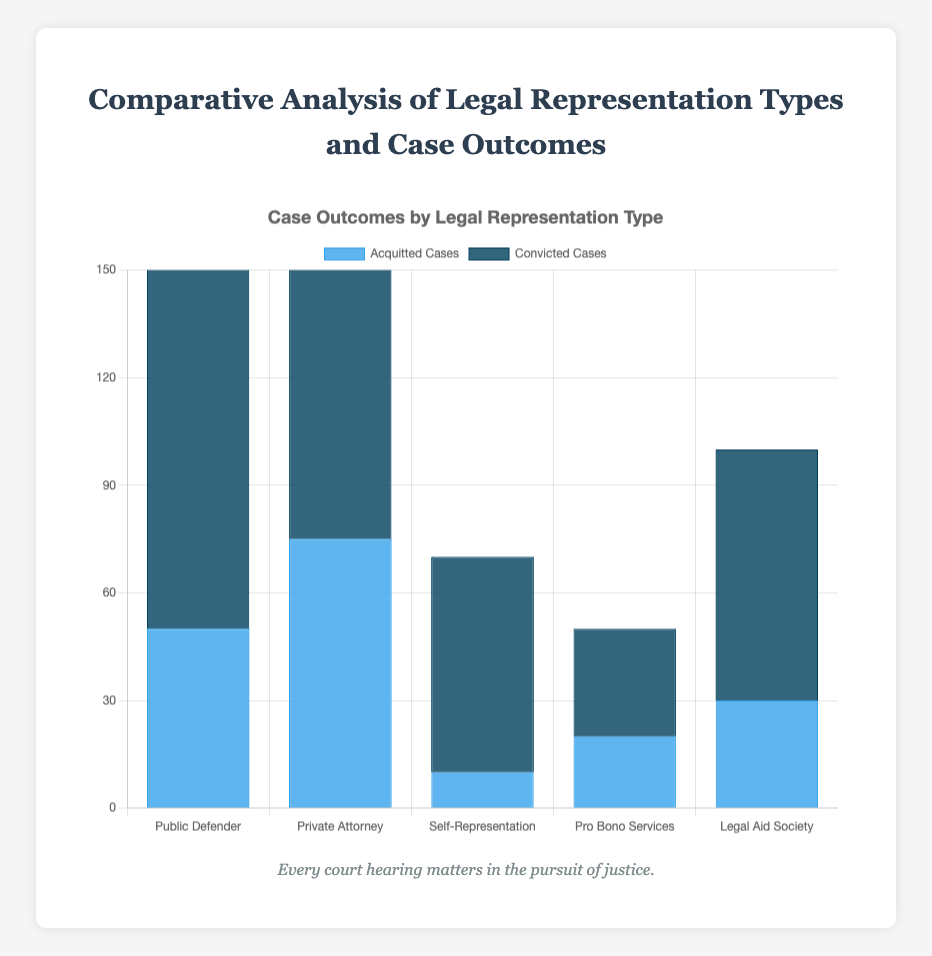What is the total number of acquitted cases for all legal representation types combined? Sum the individual acquitted cases: 50 (Public Defender) + 75 (Private Attorney) + 10 (Self-Representation) + 20 (Pro Bono Services) + 30 (Legal Aid Society) = 185
Answer: 185 Which legal representation type has the highest number of acquitted cases? Compare the acquitted cases across all types: 50 (Public Defender), 75 (Private Attorney), 10 (Self-Representation), 20 (Pro Bono Services), 30 (Legal Aid Society). Private Attorney has the highest number of acquitted cases.
Answer: Private Attorney Which legal representation type has the lowest number of convicted cases? Compare the convicted cases across all types: 120 (Public Defender), 90 (Private Attorney), 60 (Self-Representation), 30 (Pro Bono Services), 70 (Legal Aid Society). Pro Bono Services has the lowest number of convicted cases.
Answer: Pro Bono Services How many more convicted cases does Public Defender have compared to Self-Representation? Subtract the convicted cases of Self-Representation from Public Defender: 120 (Public Defender) - 60 (Self-Representation) = 60
Answer: 60 What is the average number of acquitted cases per legal representation type? Sum the acquitted cases and divide by the number of types: (50 + 75 + 10 + 20 + 30) / 5 = 185 / 5 = 37
Answer: 37 How many total cases were handled by Private Attorneys? Add acquitted and convicted cases for Private Attorney: 75 (Acquitted) + 90 (Convicted) = 165
Answer: 165 What is the ratio of acquitted to convicted cases for Legal Aid Society? Divide the number of acquitted cases by convicted cases for Legal Aid Society: 30 (Acquitted) / 70 (Convicted) = 3/7
Answer: 3/7 Which bar color represents acquitted cases in the chart? The bar color for acquitted cases is blue.
Answer: blue Among Public Defender and Pro Bono Services, which has a higher total number of cases, and by how much? Calculate total cases for each and compare: Public Defender: 50 (Acquitted) + 120 (Convicted) = 170; Pro Bono Services: 20 (Acquitted) + 30 (Convicted) = 50. Difference: 170 - 50 = 120
Answer: Public Defender by 120 What percentage of cases handled by Private Attorneys resulted in acquittals? Calculate the percentage: 75 (Acquitted) / 165 (Total Cases handled by Private Attorneys) * 100 = 45.45%
Answer: 45.45% 